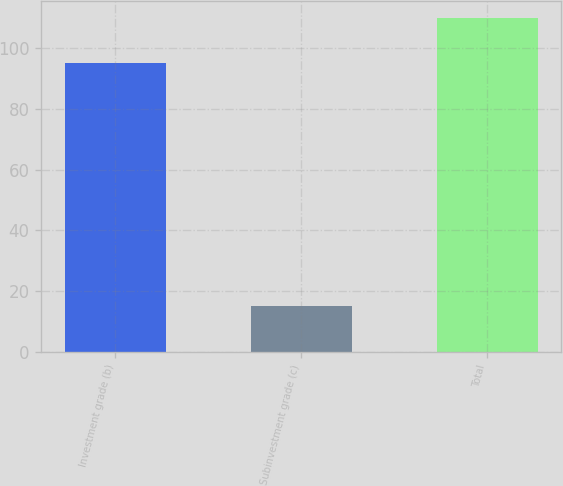Convert chart to OTSL. <chart><loc_0><loc_0><loc_500><loc_500><bar_chart><fcel>Investment grade (b)<fcel>Subinvestment grade (c)<fcel>Total<nl><fcel>95<fcel>15<fcel>110<nl></chart> 